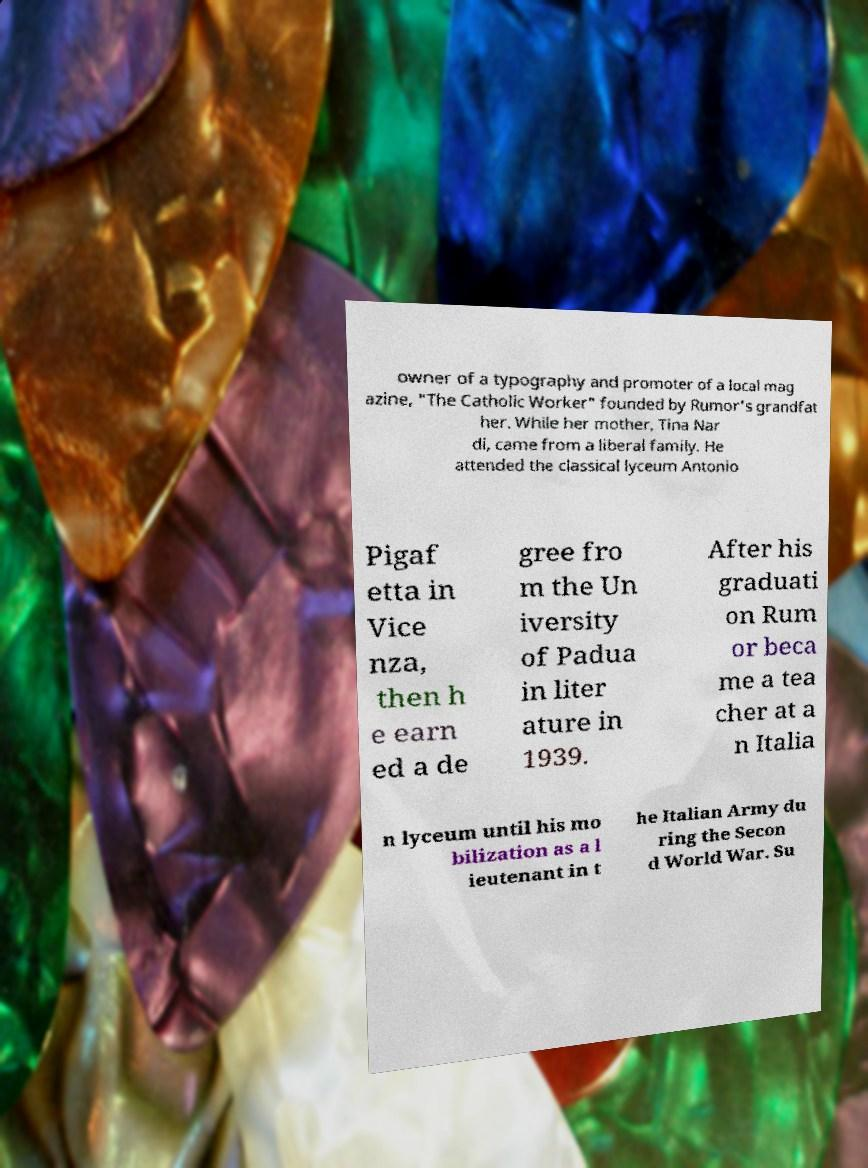Can you accurately transcribe the text from the provided image for me? owner of a typography and promoter of a local mag azine, "The Catholic Worker" founded by Rumor's grandfat her. While her mother, Tina Nar di, came from a liberal family. He attended the classical lyceum Antonio Pigaf etta in Vice nza, then h e earn ed a de gree fro m the Un iversity of Padua in liter ature in 1939. After his graduati on Rum or beca me a tea cher at a n Italia n lyceum until his mo bilization as a l ieutenant in t he Italian Army du ring the Secon d World War. Su 